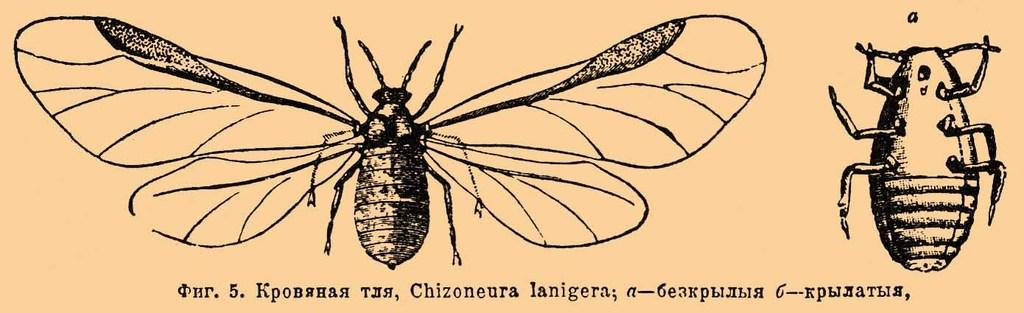What is present in the image that features a design or message? There is a poster in the image. What is depicted on the poster? The poster features a butterfly. What type of religious symbol can be seen on the poster? There is no religious symbol present on the poster; it features a butterfly. How many rabbits are visible on the poster? There are no rabbits present on the poster; it features a butterfly. 